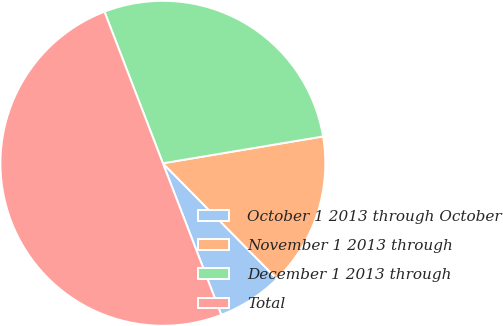Convert chart. <chart><loc_0><loc_0><loc_500><loc_500><pie_chart><fcel>October 1 2013 through October<fcel>November 1 2013 through<fcel>December 1 2013 through<fcel>Total<nl><fcel>6.54%<fcel>15.25%<fcel>28.21%<fcel>50.0%<nl></chart> 